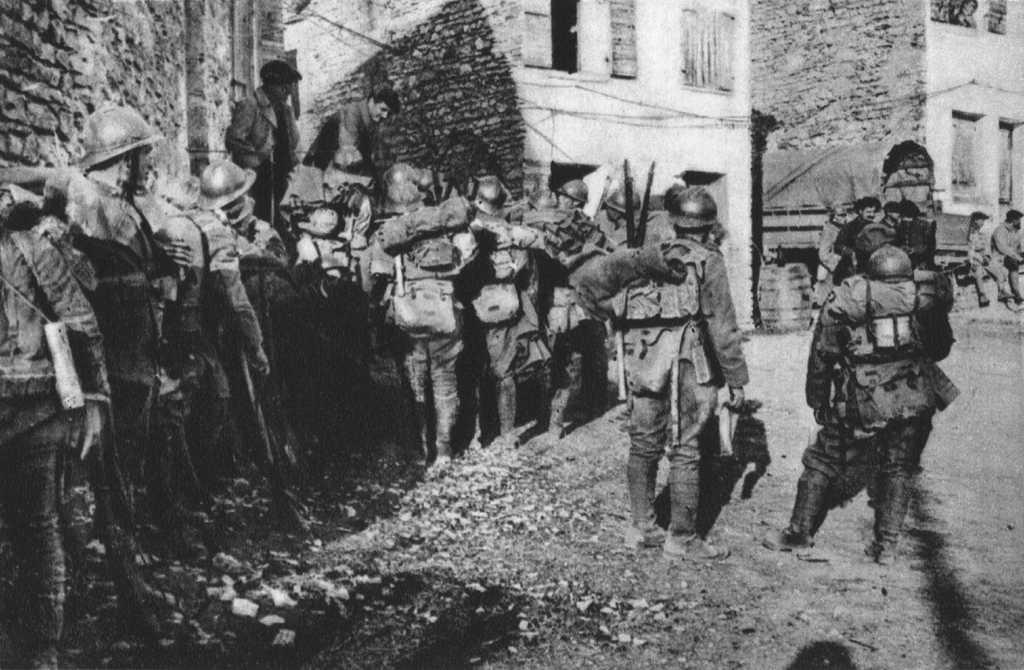What is the color scheme of the image? The image is black and white. What can be seen in terms of human presence in the image? There are groups of people standing in the image. What type of vehicle is visible in the image? There appears to be a parked vehicle in the image. What architectural features can be observed in the image? There are buildings with windows in the image. What type of liquid is being served by the government in the image? There is no reference to any liquid or government in the image; it features groups of people, a parked vehicle, and buildings with windows. 